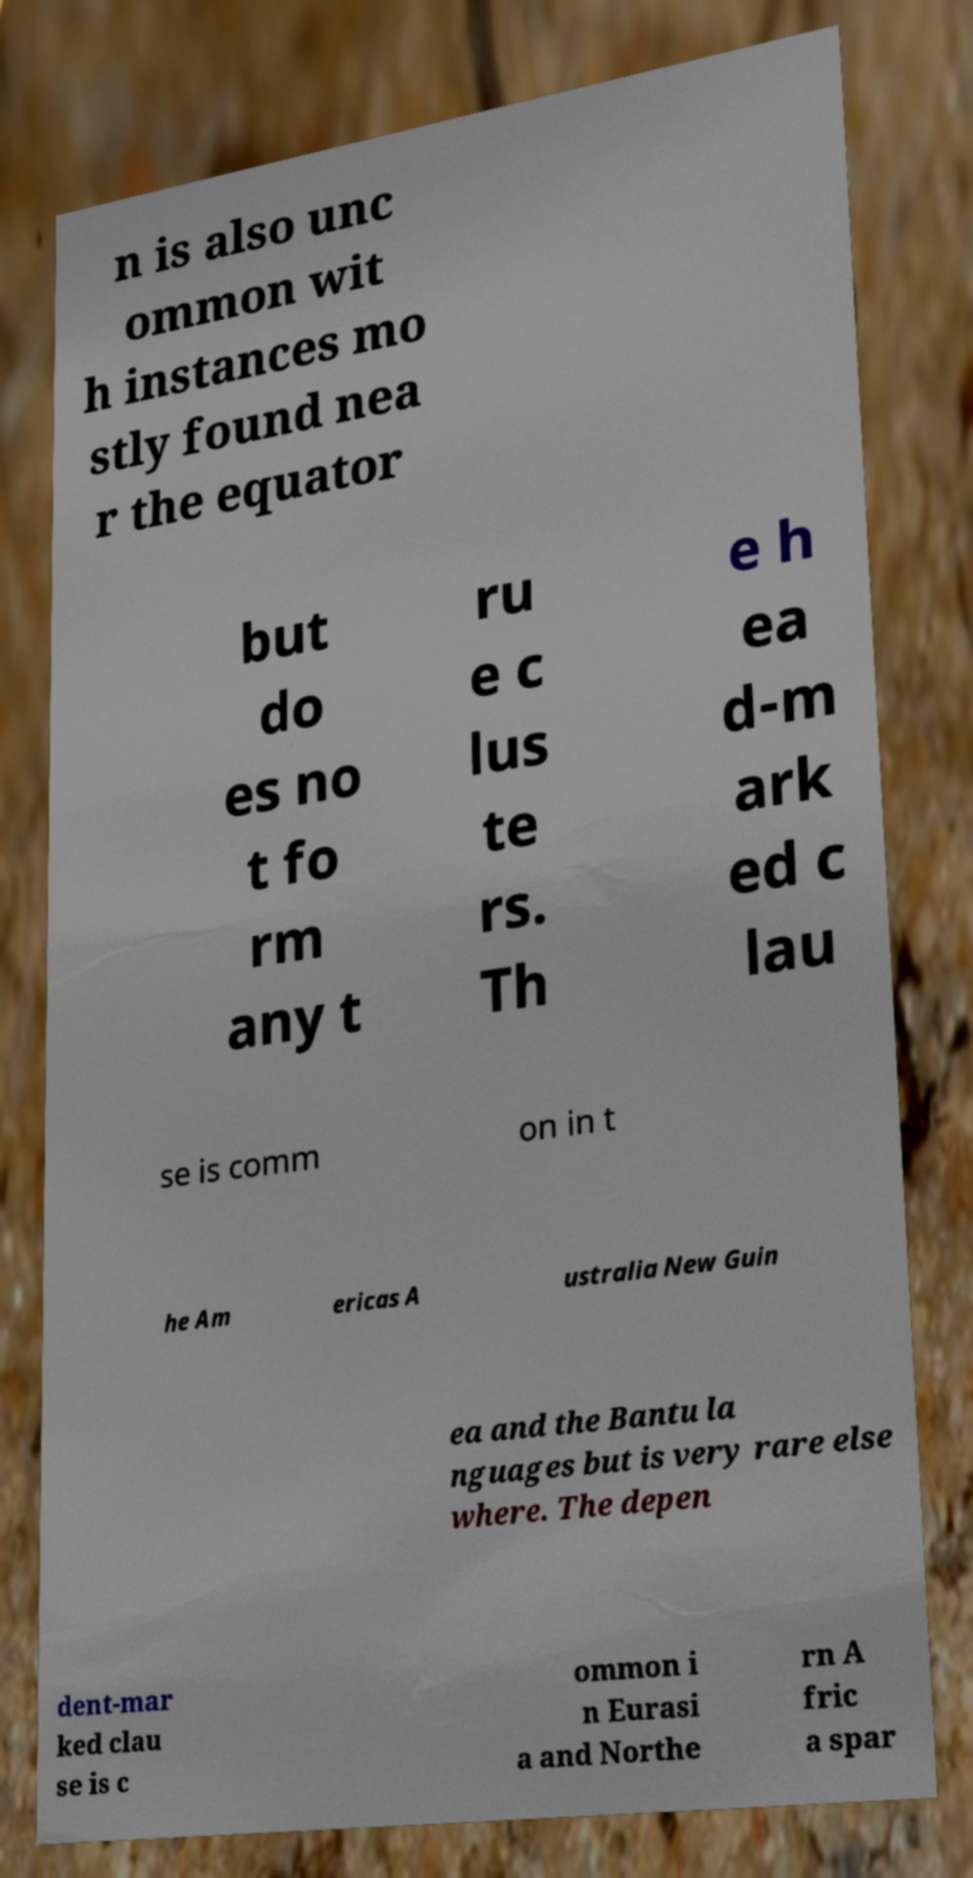Can you read and provide the text displayed in the image?This photo seems to have some interesting text. Can you extract and type it out for me? n is also unc ommon wit h instances mo stly found nea r the equator but do es no t fo rm any t ru e c lus te rs. Th e h ea d-m ark ed c lau se is comm on in t he Am ericas A ustralia New Guin ea and the Bantu la nguages but is very rare else where. The depen dent-mar ked clau se is c ommon i n Eurasi a and Northe rn A fric a spar 